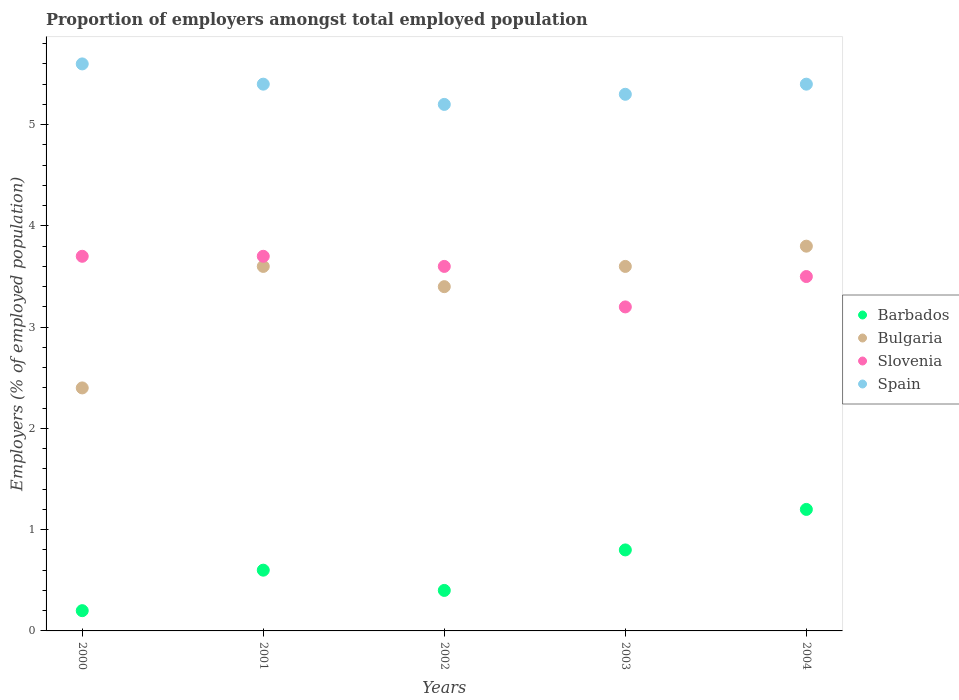Is the number of dotlines equal to the number of legend labels?
Ensure brevity in your answer.  Yes. What is the proportion of employers in Slovenia in 2001?
Your answer should be very brief. 3.7. Across all years, what is the maximum proportion of employers in Barbados?
Provide a short and direct response. 1.2. Across all years, what is the minimum proportion of employers in Slovenia?
Your answer should be compact. 3.2. In which year was the proportion of employers in Spain maximum?
Provide a succinct answer. 2000. In which year was the proportion of employers in Barbados minimum?
Give a very brief answer. 2000. What is the total proportion of employers in Spain in the graph?
Your answer should be compact. 26.9. What is the difference between the proportion of employers in Bulgaria in 2002 and that in 2004?
Your response must be concise. -0.4. What is the difference between the proportion of employers in Slovenia in 2004 and the proportion of employers in Spain in 2001?
Give a very brief answer. -1.9. What is the average proportion of employers in Barbados per year?
Offer a very short reply. 0.64. In the year 2003, what is the difference between the proportion of employers in Slovenia and proportion of employers in Bulgaria?
Your answer should be compact. -0.4. In how many years, is the proportion of employers in Spain greater than 5.6 %?
Your answer should be compact. 0. What is the ratio of the proportion of employers in Spain in 2000 to that in 2002?
Offer a very short reply. 1.08. What is the difference between the highest and the lowest proportion of employers in Spain?
Offer a terse response. 0.4. In how many years, is the proportion of employers in Spain greater than the average proportion of employers in Spain taken over all years?
Your answer should be very brief. 3. Is the sum of the proportion of employers in Spain in 2000 and 2004 greater than the maximum proportion of employers in Bulgaria across all years?
Keep it short and to the point. Yes. Is it the case that in every year, the sum of the proportion of employers in Bulgaria and proportion of employers in Slovenia  is greater than the proportion of employers in Spain?
Offer a terse response. Yes. Is the proportion of employers in Bulgaria strictly less than the proportion of employers in Barbados over the years?
Provide a short and direct response. No. How many dotlines are there?
Provide a short and direct response. 4. What is the difference between two consecutive major ticks on the Y-axis?
Keep it short and to the point. 1. Are the values on the major ticks of Y-axis written in scientific E-notation?
Offer a terse response. No. Does the graph contain any zero values?
Your answer should be very brief. No. Does the graph contain grids?
Keep it short and to the point. No. How many legend labels are there?
Your answer should be compact. 4. How are the legend labels stacked?
Your answer should be compact. Vertical. What is the title of the graph?
Provide a succinct answer. Proportion of employers amongst total employed population. Does "East Asia (all income levels)" appear as one of the legend labels in the graph?
Your response must be concise. No. What is the label or title of the X-axis?
Your answer should be very brief. Years. What is the label or title of the Y-axis?
Keep it short and to the point. Employers (% of employed population). What is the Employers (% of employed population) of Barbados in 2000?
Give a very brief answer. 0.2. What is the Employers (% of employed population) of Bulgaria in 2000?
Ensure brevity in your answer.  2.4. What is the Employers (% of employed population) in Slovenia in 2000?
Provide a succinct answer. 3.7. What is the Employers (% of employed population) of Spain in 2000?
Keep it short and to the point. 5.6. What is the Employers (% of employed population) in Barbados in 2001?
Keep it short and to the point. 0.6. What is the Employers (% of employed population) of Bulgaria in 2001?
Your response must be concise. 3.6. What is the Employers (% of employed population) of Slovenia in 2001?
Provide a succinct answer. 3.7. What is the Employers (% of employed population) in Spain in 2001?
Provide a succinct answer. 5.4. What is the Employers (% of employed population) of Barbados in 2002?
Offer a terse response. 0.4. What is the Employers (% of employed population) of Bulgaria in 2002?
Keep it short and to the point. 3.4. What is the Employers (% of employed population) of Slovenia in 2002?
Provide a short and direct response. 3.6. What is the Employers (% of employed population) of Spain in 2002?
Offer a terse response. 5.2. What is the Employers (% of employed population) in Barbados in 2003?
Your answer should be compact. 0.8. What is the Employers (% of employed population) in Bulgaria in 2003?
Provide a short and direct response. 3.6. What is the Employers (% of employed population) in Slovenia in 2003?
Give a very brief answer. 3.2. What is the Employers (% of employed population) in Spain in 2003?
Make the answer very short. 5.3. What is the Employers (% of employed population) in Barbados in 2004?
Your response must be concise. 1.2. What is the Employers (% of employed population) in Bulgaria in 2004?
Offer a very short reply. 3.8. What is the Employers (% of employed population) of Slovenia in 2004?
Offer a very short reply. 3.5. What is the Employers (% of employed population) in Spain in 2004?
Provide a succinct answer. 5.4. Across all years, what is the maximum Employers (% of employed population) of Barbados?
Provide a short and direct response. 1.2. Across all years, what is the maximum Employers (% of employed population) of Bulgaria?
Your answer should be compact. 3.8. Across all years, what is the maximum Employers (% of employed population) in Slovenia?
Provide a short and direct response. 3.7. Across all years, what is the maximum Employers (% of employed population) in Spain?
Make the answer very short. 5.6. Across all years, what is the minimum Employers (% of employed population) of Barbados?
Provide a short and direct response. 0.2. Across all years, what is the minimum Employers (% of employed population) in Bulgaria?
Provide a succinct answer. 2.4. Across all years, what is the minimum Employers (% of employed population) of Slovenia?
Your response must be concise. 3.2. Across all years, what is the minimum Employers (% of employed population) of Spain?
Provide a succinct answer. 5.2. What is the total Employers (% of employed population) in Spain in the graph?
Your answer should be very brief. 26.9. What is the difference between the Employers (% of employed population) of Barbados in 2000 and that in 2001?
Offer a terse response. -0.4. What is the difference between the Employers (% of employed population) in Slovenia in 2000 and that in 2001?
Make the answer very short. 0. What is the difference between the Employers (% of employed population) in Spain in 2000 and that in 2001?
Provide a succinct answer. 0.2. What is the difference between the Employers (% of employed population) in Bulgaria in 2000 and that in 2002?
Your response must be concise. -1. What is the difference between the Employers (% of employed population) of Slovenia in 2000 and that in 2002?
Provide a short and direct response. 0.1. What is the difference between the Employers (% of employed population) of Spain in 2000 and that in 2002?
Your response must be concise. 0.4. What is the difference between the Employers (% of employed population) in Bulgaria in 2000 and that in 2003?
Ensure brevity in your answer.  -1.2. What is the difference between the Employers (% of employed population) of Spain in 2000 and that in 2003?
Make the answer very short. 0.3. What is the difference between the Employers (% of employed population) of Slovenia in 2000 and that in 2004?
Give a very brief answer. 0.2. What is the difference between the Employers (% of employed population) in Slovenia in 2001 and that in 2003?
Make the answer very short. 0.5. What is the difference between the Employers (% of employed population) in Barbados in 2001 and that in 2004?
Offer a terse response. -0.6. What is the difference between the Employers (% of employed population) of Bulgaria in 2001 and that in 2004?
Offer a very short reply. -0.2. What is the difference between the Employers (% of employed population) in Spain in 2001 and that in 2004?
Offer a very short reply. 0. What is the difference between the Employers (% of employed population) in Barbados in 2002 and that in 2003?
Give a very brief answer. -0.4. What is the difference between the Employers (% of employed population) in Spain in 2002 and that in 2003?
Your response must be concise. -0.1. What is the difference between the Employers (% of employed population) in Slovenia in 2002 and that in 2004?
Give a very brief answer. 0.1. What is the difference between the Employers (% of employed population) in Spain in 2002 and that in 2004?
Keep it short and to the point. -0.2. What is the difference between the Employers (% of employed population) of Barbados in 2003 and that in 2004?
Make the answer very short. -0.4. What is the difference between the Employers (% of employed population) in Bulgaria in 2003 and that in 2004?
Provide a succinct answer. -0.2. What is the difference between the Employers (% of employed population) of Slovenia in 2003 and that in 2004?
Provide a short and direct response. -0.3. What is the difference between the Employers (% of employed population) in Barbados in 2000 and the Employers (% of employed population) in Slovenia in 2001?
Give a very brief answer. -3.5. What is the difference between the Employers (% of employed population) of Slovenia in 2000 and the Employers (% of employed population) of Spain in 2001?
Your answer should be compact. -1.7. What is the difference between the Employers (% of employed population) in Barbados in 2000 and the Employers (% of employed population) in Bulgaria in 2002?
Ensure brevity in your answer.  -3.2. What is the difference between the Employers (% of employed population) of Barbados in 2000 and the Employers (% of employed population) of Slovenia in 2002?
Provide a short and direct response. -3.4. What is the difference between the Employers (% of employed population) in Bulgaria in 2000 and the Employers (% of employed population) in Slovenia in 2002?
Make the answer very short. -1.2. What is the difference between the Employers (% of employed population) in Bulgaria in 2000 and the Employers (% of employed population) in Spain in 2002?
Keep it short and to the point. -2.8. What is the difference between the Employers (% of employed population) of Slovenia in 2000 and the Employers (% of employed population) of Spain in 2002?
Your answer should be compact. -1.5. What is the difference between the Employers (% of employed population) in Barbados in 2000 and the Employers (% of employed population) in Slovenia in 2003?
Provide a short and direct response. -3. What is the difference between the Employers (% of employed population) of Bulgaria in 2000 and the Employers (% of employed population) of Slovenia in 2003?
Give a very brief answer. -0.8. What is the difference between the Employers (% of employed population) in Bulgaria in 2000 and the Employers (% of employed population) in Spain in 2003?
Make the answer very short. -2.9. What is the difference between the Employers (% of employed population) of Slovenia in 2000 and the Employers (% of employed population) of Spain in 2003?
Offer a terse response. -1.6. What is the difference between the Employers (% of employed population) of Barbados in 2000 and the Employers (% of employed population) of Bulgaria in 2004?
Offer a very short reply. -3.6. What is the difference between the Employers (% of employed population) in Bulgaria in 2000 and the Employers (% of employed population) in Slovenia in 2004?
Your answer should be very brief. -1.1. What is the difference between the Employers (% of employed population) of Barbados in 2001 and the Employers (% of employed population) of Bulgaria in 2002?
Ensure brevity in your answer.  -2.8. What is the difference between the Employers (% of employed population) of Barbados in 2001 and the Employers (% of employed population) of Bulgaria in 2003?
Your response must be concise. -3. What is the difference between the Employers (% of employed population) of Barbados in 2001 and the Employers (% of employed population) of Spain in 2003?
Offer a very short reply. -4.7. What is the difference between the Employers (% of employed population) in Bulgaria in 2001 and the Employers (% of employed population) in Slovenia in 2003?
Offer a terse response. 0.4. What is the difference between the Employers (% of employed population) in Bulgaria in 2001 and the Employers (% of employed population) in Spain in 2003?
Give a very brief answer. -1.7. What is the difference between the Employers (% of employed population) of Slovenia in 2001 and the Employers (% of employed population) of Spain in 2003?
Your response must be concise. -1.6. What is the difference between the Employers (% of employed population) in Barbados in 2001 and the Employers (% of employed population) in Bulgaria in 2004?
Your response must be concise. -3.2. What is the difference between the Employers (% of employed population) in Barbados in 2001 and the Employers (% of employed population) in Slovenia in 2004?
Provide a succinct answer. -2.9. What is the difference between the Employers (% of employed population) of Barbados in 2001 and the Employers (% of employed population) of Spain in 2004?
Ensure brevity in your answer.  -4.8. What is the difference between the Employers (% of employed population) in Bulgaria in 2001 and the Employers (% of employed population) in Slovenia in 2004?
Your answer should be very brief. 0.1. What is the difference between the Employers (% of employed population) in Bulgaria in 2001 and the Employers (% of employed population) in Spain in 2004?
Provide a short and direct response. -1.8. What is the difference between the Employers (% of employed population) of Slovenia in 2002 and the Employers (% of employed population) of Spain in 2003?
Give a very brief answer. -1.7. What is the difference between the Employers (% of employed population) of Bulgaria in 2002 and the Employers (% of employed population) of Slovenia in 2004?
Give a very brief answer. -0.1. What is the difference between the Employers (% of employed population) of Barbados in 2003 and the Employers (% of employed population) of Slovenia in 2004?
Ensure brevity in your answer.  -2.7. What is the difference between the Employers (% of employed population) of Barbados in 2003 and the Employers (% of employed population) of Spain in 2004?
Offer a terse response. -4.6. What is the difference between the Employers (% of employed population) of Bulgaria in 2003 and the Employers (% of employed population) of Spain in 2004?
Your answer should be very brief. -1.8. What is the difference between the Employers (% of employed population) of Slovenia in 2003 and the Employers (% of employed population) of Spain in 2004?
Provide a short and direct response. -2.2. What is the average Employers (% of employed population) of Barbados per year?
Your answer should be very brief. 0.64. What is the average Employers (% of employed population) in Bulgaria per year?
Offer a very short reply. 3.36. What is the average Employers (% of employed population) of Slovenia per year?
Give a very brief answer. 3.54. What is the average Employers (% of employed population) in Spain per year?
Keep it short and to the point. 5.38. In the year 2000, what is the difference between the Employers (% of employed population) of Barbados and Employers (% of employed population) of Bulgaria?
Make the answer very short. -2.2. In the year 2000, what is the difference between the Employers (% of employed population) in Slovenia and Employers (% of employed population) in Spain?
Give a very brief answer. -1.9. In the year 2001, what is the difference between the Employers (% of employed population) in Barbados and Employers (% of employed population) in Slovenia?
Keep it short and to the point. -3.1. In the year 2001, what is the difference between the Employers (% of employed population) of Barbados and Employers (% of employed population) of Spain?
Provide a short and direct response. -4.8. In the year 2001, what is the difference between the Employers (% of employed population) of Bulgaria and Employers (% of employed population) of Slovenia?
Offer a terse response. -0.1. In the year 2001, what is the difference between the Employers (% of employed population) in Slovenia and Employers (% of employed population) in Spain?
Ensure brevity in your answer.  -1.7. In the year 2002, what is the difference between the Employers (% of employed population) of Barbados and Employers (% of employed population) of Bulgaria?
Your answer should be compact. -3. In the year 2002, what is the difference between the Employers (% of employed population) in Bulgaria and Employers (% of employed population) in Spain?
Your answer should be very brief. -1.8. In the year 2003, what is the difference between the Employers (% of employed population) in Barbados and Employers (% of employed population) in Bulgaria?
Provide a succinct answer. -2.8. In the year 2003, what is the difference between the Employers (% of employed population) of Slovenia and Employers (% of employed population) of Spain?
Give a very brief answer. -2.1. In the year 2004, what is the difference between the Employers (% of employed population) of Barbados and Employers (% of employed population) of Bulgaria?
Your answer should be very brief. -2.6. In the year 2004, what is the difference between the Employers (% of employed population) in Barbados and Employers (% of employed population) in Slovenia?
Offer a terse response. -2.3. In the year 2004, what is the difference between the Employers (% of employed population) of Bulgaria and Employers (% of employed population) of Slovenia?
Offer a terse response. 0.3. In the year 2004, what is the difference between the Employers (% of employed population) of Bulgaria and Employers (% of employed population) of Spain?
Offer a very short reply. -1.6. In the year 2004, what is the difference between the Employers (% of employed population) of Slovenia and Employers (% of employed population) of Spain?
Provide a succinct answer. -1.9. What is the ratio of the Employers (% of employed population) of Barbados in 2000 to that in 2001?
Your answer should be compact. 0.33. What is the ratio of the Employers (% of employed population) in Bulgaria in 2000 to that in 2001?
Offer a terse response. 0.67. What is the ratio of the Employers (% of employed population) in Spain in 2000 to that in 2001?
Provide a succinct answer. 1.04. What is the ratio of the Employers (% of employed population) in Barbados in 2000 to that in 2002?
Provide a short and direct response. 0.5. What is the ratio of the Employers (% of employed population) of Bulgaria in 2000 to that in 2002?
Provide a short and direct response. 0.71. What is the ratio of the Employers (% of employed population) of Slovenia in 2000 to that in 2002?
Ensure brevity in your answer.  1.03. What is the ratio of the Employers (% of employed population) of Slovenia in 2000 to that in 2003?
Your answer should be very brief. 1.16. What is the ratio of the Employers (% of employed population) of Spain in 2000 to that in 2003?
Your response must be concise. 1.06. What is the ratio of the Employers (% of employed population) of Bulgaria in 2000 to that in 2004?
Provide a short and direct response. 0.63. What is the ratio of the Employers (% of employed population) of Slovenia in 2000 to that in 2004?
Give a very brief answer. 1.06. What is the ratio of the Employers (% of employed population) of Spain in 2000 to that in 2004?
Provide a succinct answer. 1.04. What is the ratio of the Employers (% of employed population) of Bulgaria in 2001 to that in 2002?
Offer a terse response. 1.06. What is the ratio of the Employers (% of employed population) of Slovenia in 2001 to that in 2002?
Offer a very short reply. 1.03. What is the ratio of the Employers (% of employed population) in Spain in 2001 to that in 2002?
Your answer should be very brief. 1.04. What is the ratio of the Employers (% of employed population) of Barbados in 2001 to that in 2003?
Provide a short and direct response. 0.75. What is the ratio of the Employers (% of employed population) in Slovenia in 2001 to that in 2003?
Your answer should be compact. 1.16. What is the ratio of the Employers (% of employed population) of Spain in 2001 to that in 2003?
Provide a succinct answer. 1.02. What is the ratio of the Employers (% of employed population) of Bulgaria in 2001 to that in 2004?
Offer a very short reply. 0.95. What is the ratio of the Employers (% of employed population) in Slovenia in 2001 to that in 2004?
Ensure brevity in your answer.  1.06. What is the ratio of the Employers (% of employed population) in Spain in 2002 to that in 2003?
Your response must be concise. 0.98. What is the ratio of the Employers (% of employed population) of Barbados in 2002 to that in 2004?
Provide a short and direct response. 0.33. What is the ratio of the Employers (% of employed population) of Bulgaria in 2002 to that in 2004?
Provide a short and direct response. 0.89. What is the ratio of the Employers (% of employed population) in Slovenia in 2002 to that in 2004?
Provide a short and direct response. 1.03. What is the ratio of the Employers (% of employed population) of Bulgaria in 2003 to that in 2004?
Give a very brief answer. 0.95. What is the ratio of the Employers (% of employed population) of Slovenia in 2003 to that in 2004?
Your response must be concise. 0.91. What is the ratio of the Employers (% of employed population) of Spain in 2003 to that in 2004?
Your answer should be very brief. 0.98. What is the difference between the highest and the second highest Employers (% of employed population) in Barbados?
Ensure brevity in your answer.  0.4. What is the difference between the highest and the second highest Employers (% of employed population) of Slovenia?
Ensure brevity in your answer.  0. 